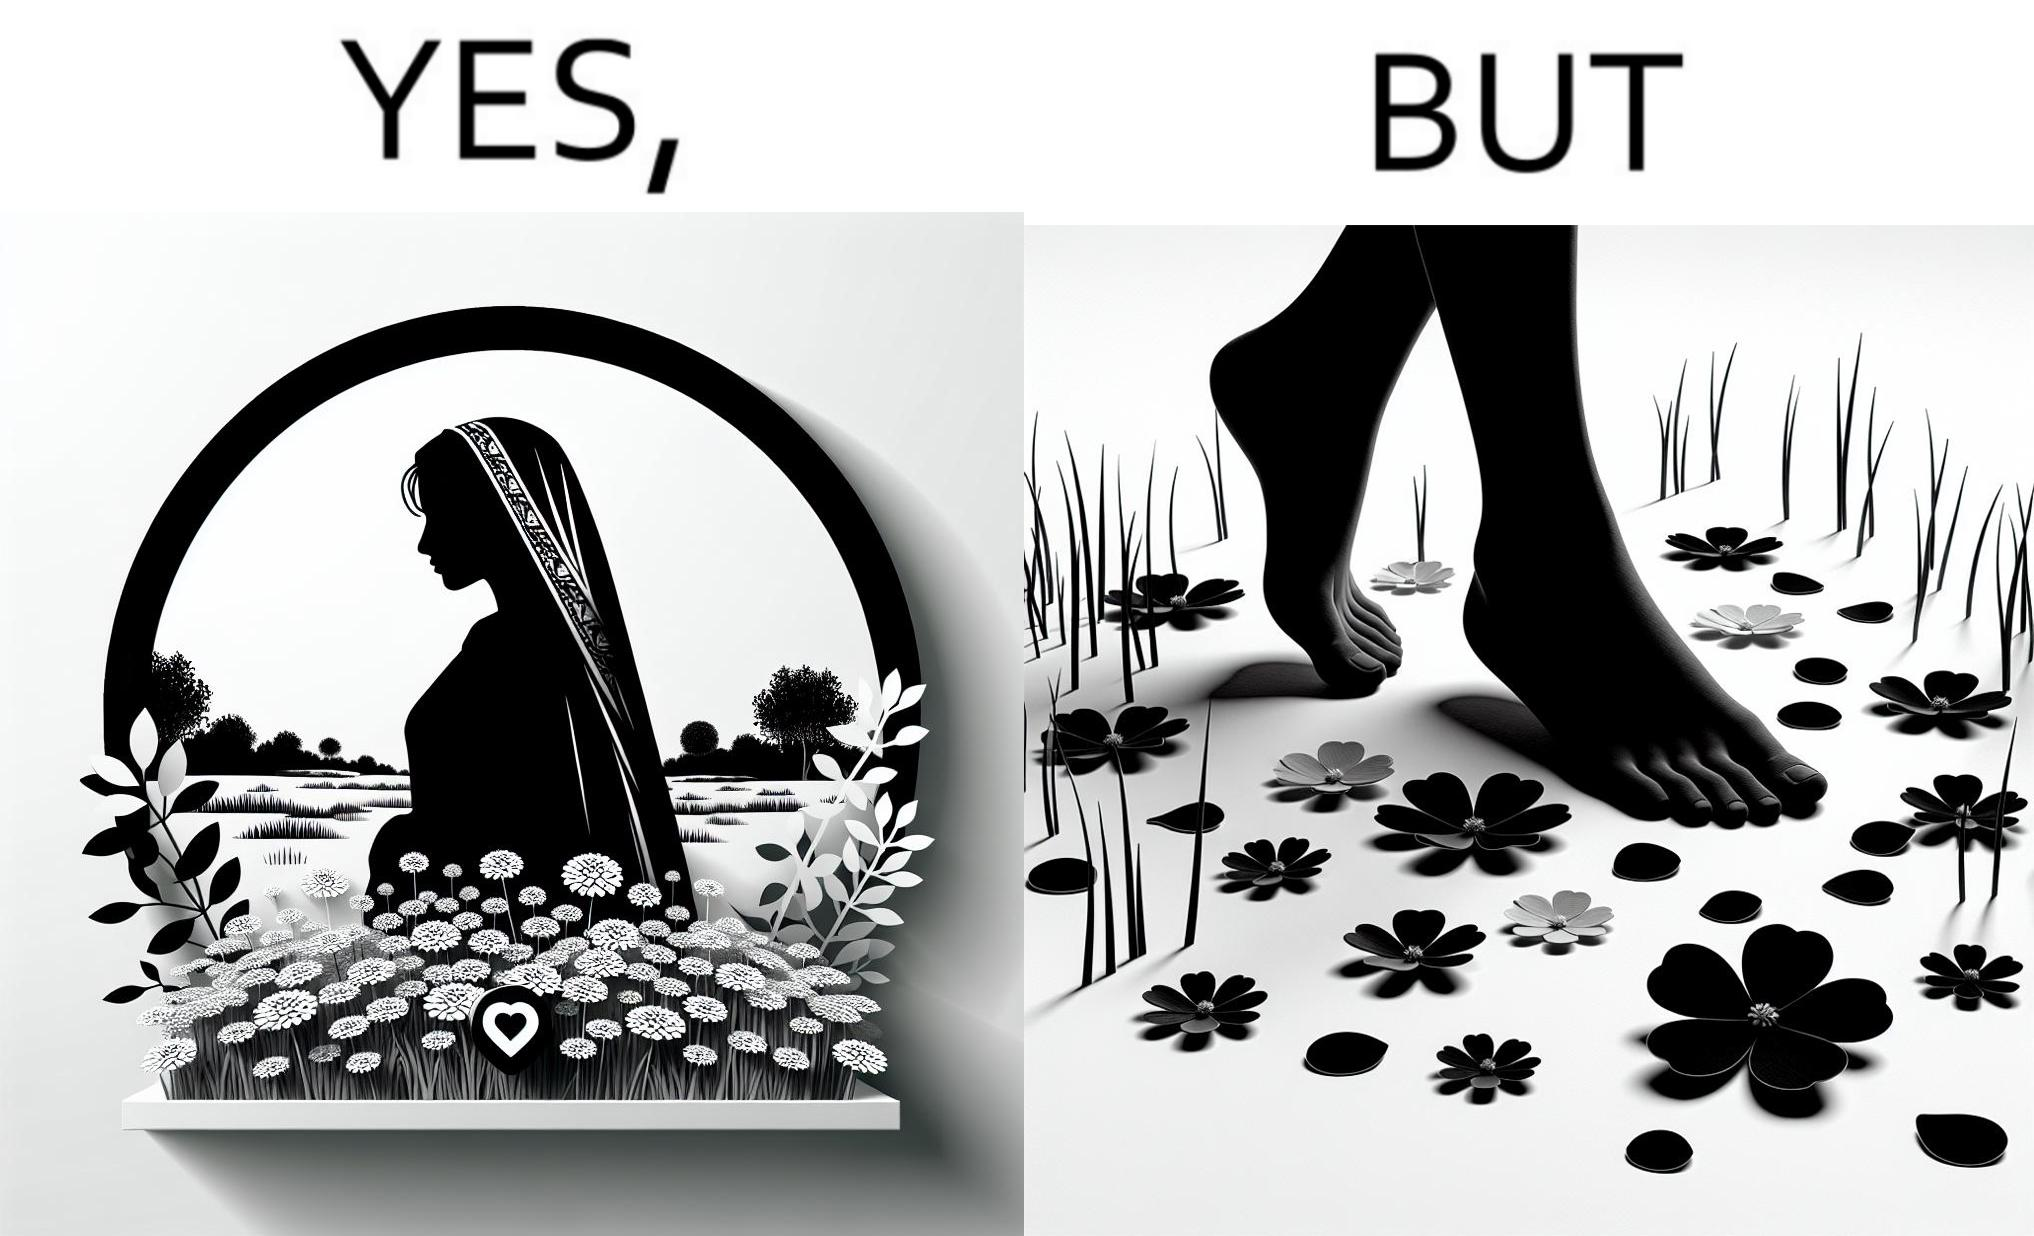Describe the content of this image. The image is ironical, as the social ,edia post shows the appreciation of nature, while an image of the feet on the ground stepping on the flower petals shows an unintentional disrespect of nature. 